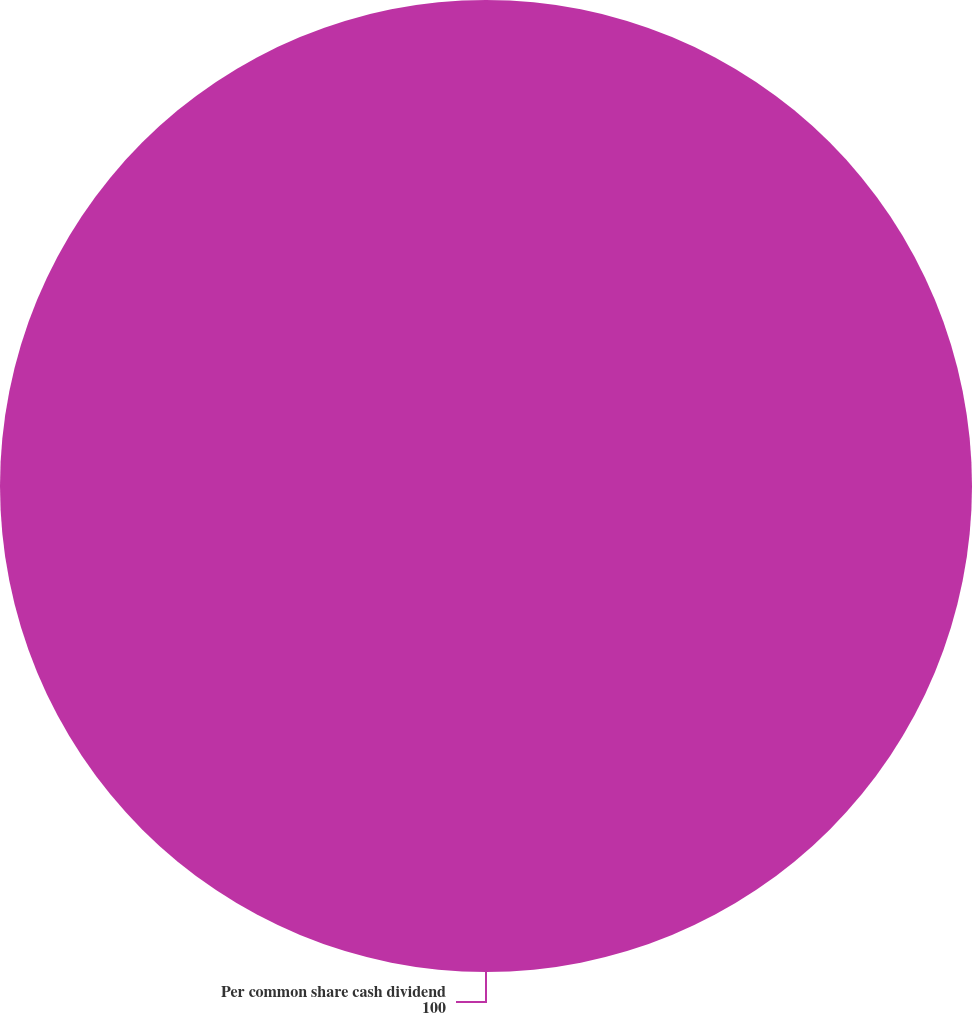<chart> <loc_0><loc_0><loc_500><loc_500><pie_chart><fcel>Per common share cash dividend<nl><fcel>100.0%<nl></chart> 